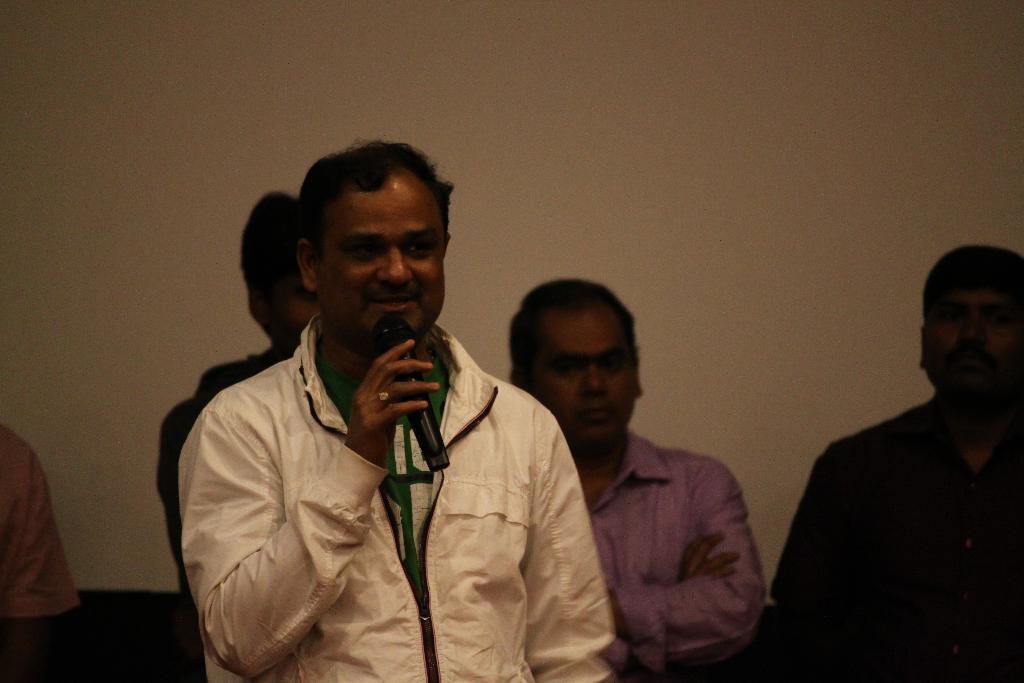How would you summarize this image in a sentence or two? In this image we can see some people standing near the wall, one object near to the wall, one man with cream color jacket holding a microphone and talking. 